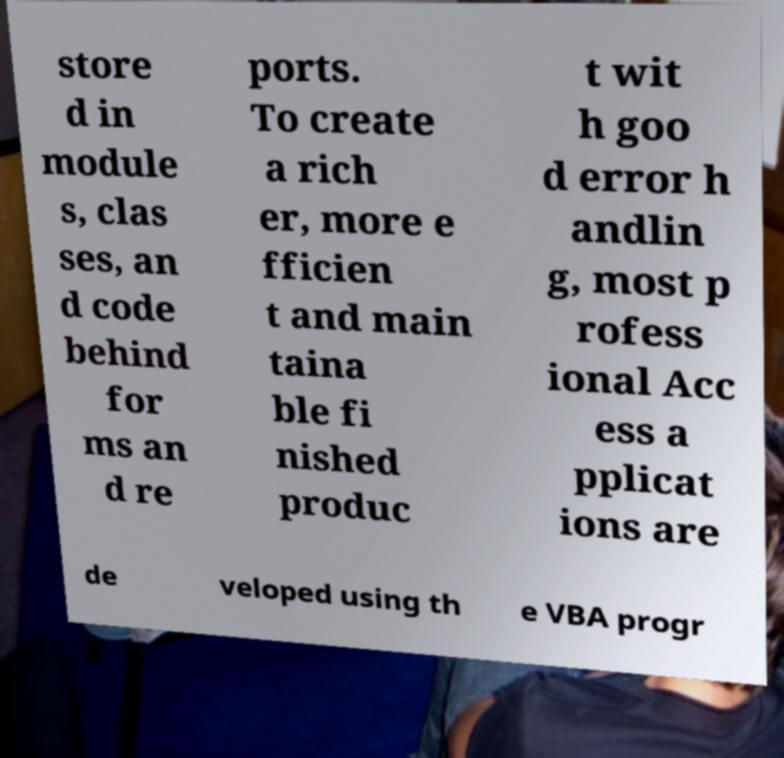There's text embedded in this image that I need extracted. Can you transcribe it verbatim? store d in module s, clas ses, an d code behind for ms an d re ports. To create a rich er, more e fficien t and main taina ble fi nished produc t wit h goo d error h andlin g, most p rofess ional Acc ess a pplicat ions are de veloped using th e VBA progr 